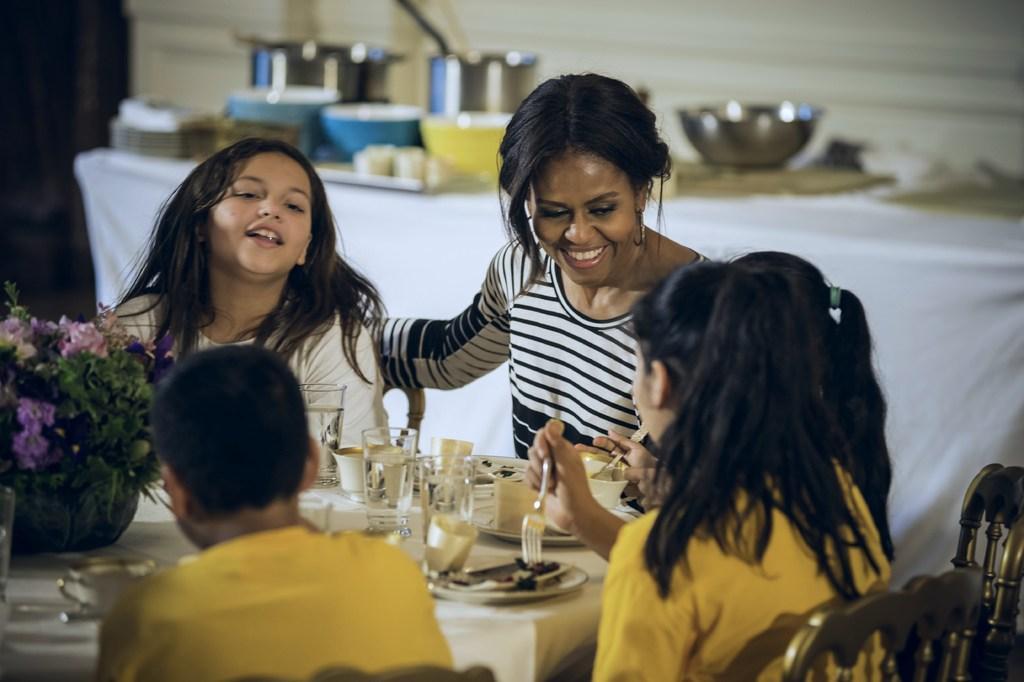In one or two sentences, can you explain what this image depicts? In the foreground of the picture there are kids, woman, flower pot, plates, glasses, food items, chairs, table and other objects. In the background there are vessels, table, cloth and other objects. 